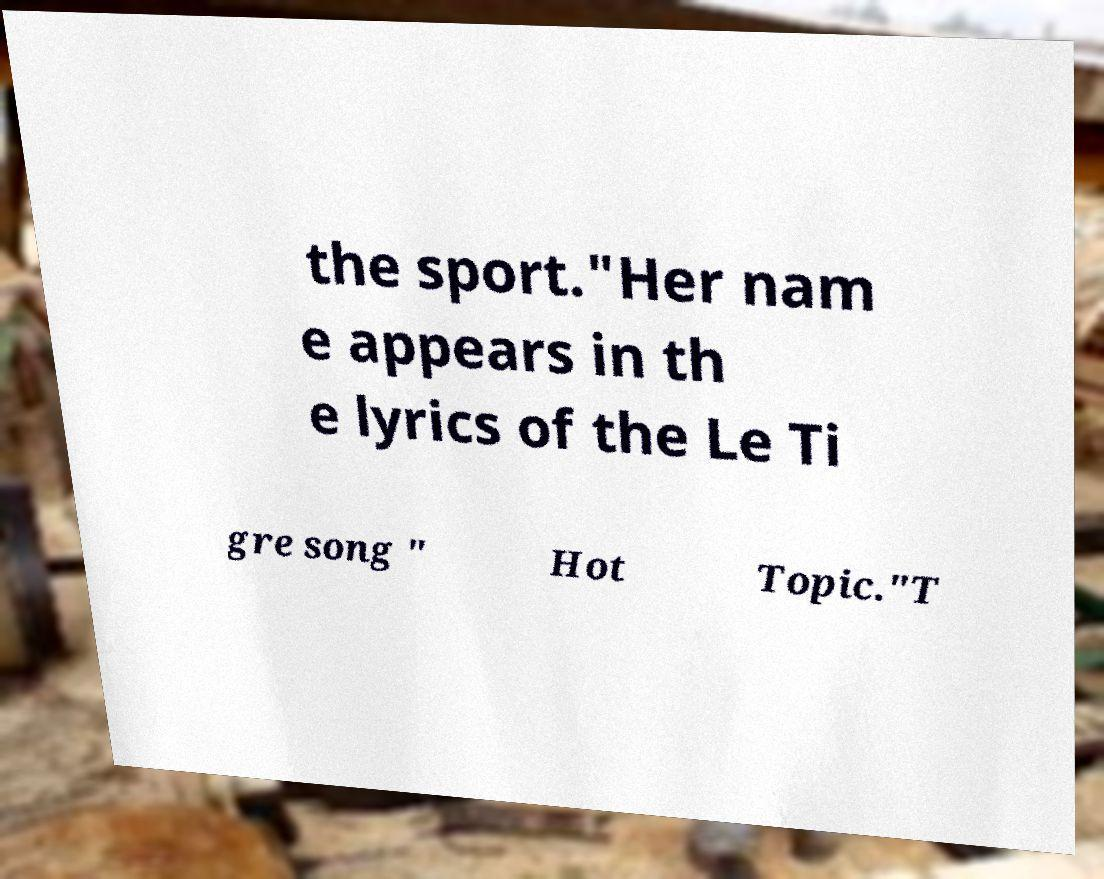I need the written content from this picture converted into text. Can you do that? the sport."Her nam e appears in th e lyrics of the Le Ti gre song " Hot Topic."T 